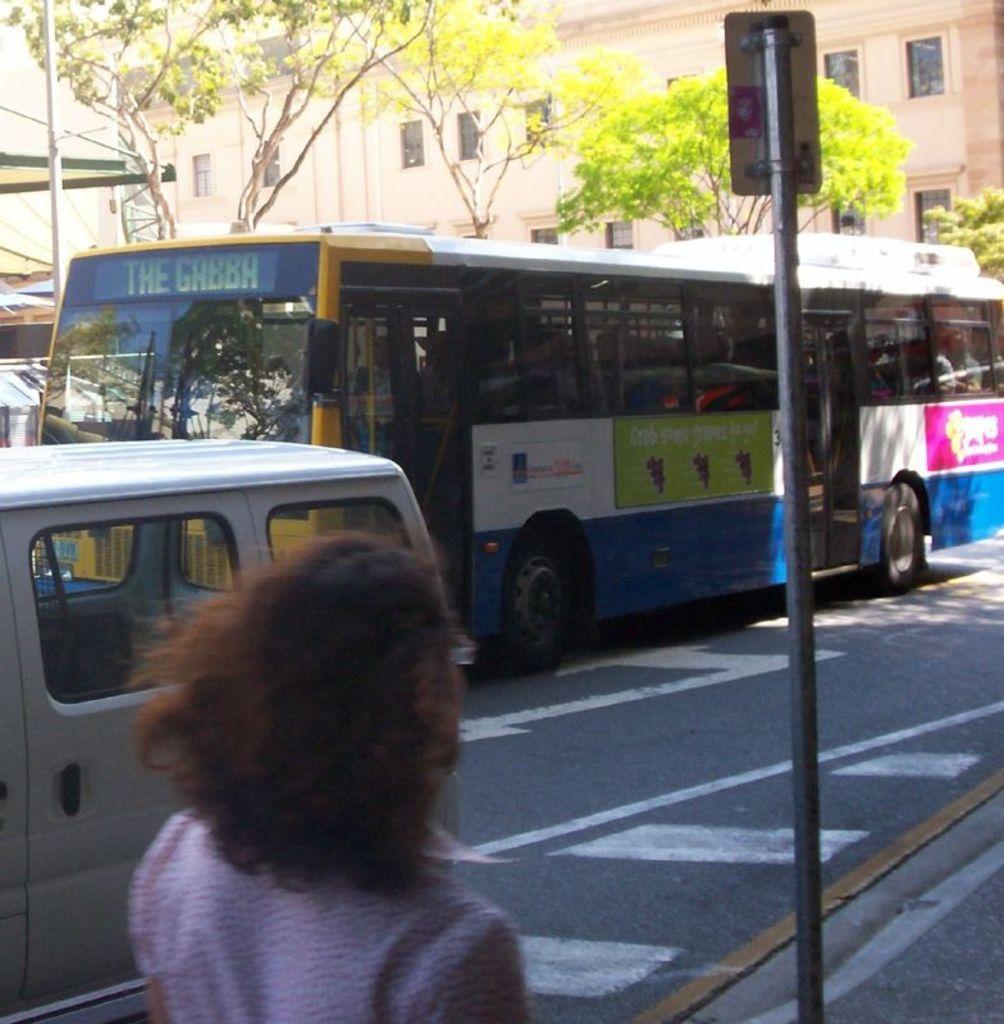Please provide a concise description of this image. In this image I can see a person wearing pink colored dress is standing on the sidewalk, a pole, the road, few vehicles on the road, few trees and few buildings. In the background I can see the sky. 